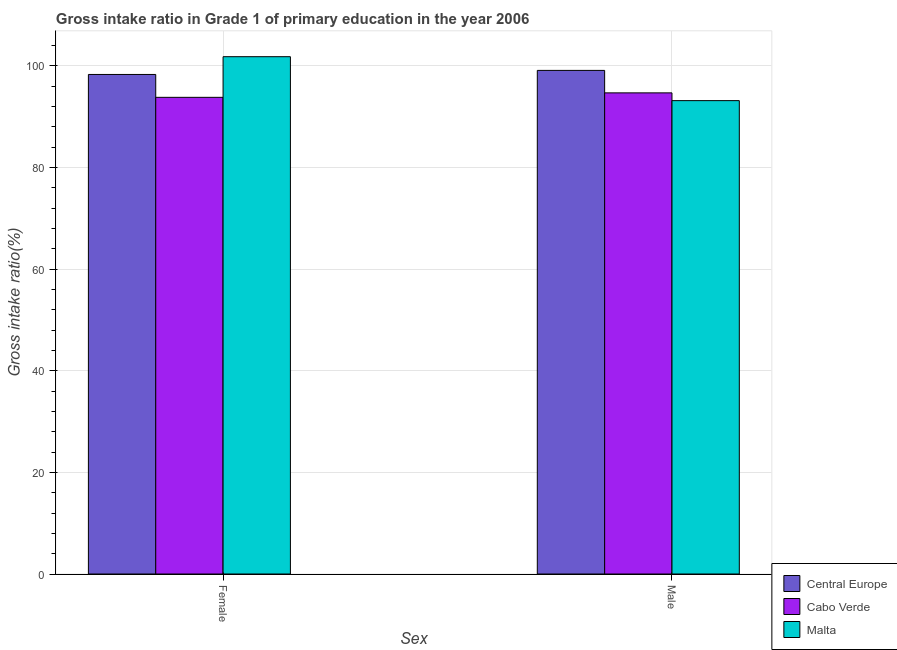How many groups of bars are there?
Make the answer very short. 2. How many bars are there on the 1st tick from the left?
Make the answer very short. 3. How many bars are there on the 1st tick from the right?
Keep it short and to the point. 3. What is the gross intake ratio(male) in Cabo Verde?
Provide a succinct answer. 94.66. Across all countries, what is the maximum gross intake ratio(male)?
Your answer should be very brief. 99.08. Across all countries, what is the minimum gross intake ratio(male)?
Provide a short and direct response. 93.13. In which country was the gross intake ratio(male) maximum?
Offer a very short reply. Central Europe. In which country was the gross intake ratio(male) minimum?
Provide a succinct answer. Malta. What is the total gross intake ratio(male) in the graph?
Your answer should be very brief. 286.87. What is the difference between the gross intake ratio(female) in Cabo Verde and that in Malta?
Keep it short and to the point. -8. What is the difference between the gross intake ratio(female) in Malta and the gross intake ratio(male) in Central Europe?
Ensure brevity in your answer.  2.7. What is the average gross intake ratio(female) per country?
Your answer should be very brief. 97.95. What is the difference between the gross intake ratio(male) and gross intake ratio(female) in Malta?
Keep it short and to the point. -8.65. In how many countries, is the gross intake ratio(female) greater than 64 %?
Make the answer very short. 3. What is the ratio of the gross intake ratio(female) in Central Europe to that in Cabo Verde?
Keep it short and to the point. 1.05. What does the 3rd bar from the left in Female represents?
Provide a succinct answer. Malta. What does the 1st bar from the right in Male represents?
Your answer should be very brief. Malta. How many bars are there?
Ensure brevity in your answer.  6. Are all the bars in the graph horizontal?
Make the answer very short. No. How many countries are there in the graph?
Your answer should be compact. 3. What is the difference between two consecutive major ticks on the Y-axis?
Make the answer very short. 20. Are the values on the major ticks of Y-axis written in scientific E-notation?
Provide a short and direct response. No. Does the graph contain any zero values?
Your response must be concise. No. Where does the legend appear in the graph?
Offer a terse response. Bottom right. How are the legend labels stacked?
Give a very brief answer. Vertical. What is the title of the graph?
Provide a succinct answer. Gross intake ratio in Grade 1 of primary education in the year 2006. Does "United Arab Emirates" appear as one of the legend labels in the graph?
Keep it short and to the point. No. What is the label or title of the X-axis?
Give a very brief answer. Sex. What is the label or title of the Y-axis?
Make the answer very short. Gross intake ratio(%). What is the Gross intake ratio(%) in Central Europe in Female?
Your answer should be compact. 98.28. What is the Gross intake ratio(%) in Cabo Verde in Female?
Your answer should be very brief. 93.78. What is the Gross intake ratio(%) in Malta in Female?
Offer a very short reply. 101.78. What is the Gross intake ratio(%) in Central Europe in Male?
Offer a terse response. 99.08. What is the Gross intake ratio(%) in Cabo Verde in Male?
Offer a very short reply. 94.66. What is the Gross intake ratio(%) of Malta in Male?
Keep it short and to the point. 93.13. Across all Sex, what is the maximum Gross intake ratio(%) in Central Europe?
Your answer should be compact. 99.08. Across all Sex, what is the maximum Gross intake ratio(%) in Cabo Verde?
Make the answer very short. 94.66. Across all Sex, what is the maximum Gross intake ratio(%) of Malta?
Your response must be concise. 101.78. Across all Sex, what is the minimum Gross intake ratio(%) of Central Europe?
Make the answer very short. 98.28. Across all Sex, what is the minimum Gross intake ratio(%) in Cabo Verde?
Offer a very short reply. 93.78. Across all Sex, what is the minimum Gross intake ratio(%) in Malta?
Give a very brief answer. 93.13. What is the total Gross intake ratio(%) in Central Europe in the graph?
Keep it short and to the point. 197.36. What is the total Gross intake ratio(%) of Cabo Verde in the graph?
Provide a succinct answer. 188.44. What is the total Gross intake ratio(%) in Malta in the graph?
Provide a short and direct response. 194.91. What is the difference between the Gross intake ratio(%) in Central Europe in Female and that in Male?
Provide a short and direct response. -0.8. What is the difference between the Gross intake ratio(%) in Cabo Verde in Female and that in Male?
Give a very brief answer. -0.88. What is the difference between the Gross intake ratio(%) in Malta in Female and that in Male?
Provide a succinct answer. 8.65. What is the difference between the Gross intake ratio(%) of Central Europe in Female and the Gross intake ratio(%) of Cabo Verde in Male?
Offer a terse response. 3.62. What is the difference between the Gross intake ratio(%) of Central Europe in Female and the Gross intake ratio(%) of Malta in Male?
Offer a very short reply. 5.15. What is the difference between the Gross intake ratio(%) of Cabo Verde in Female and the Gross intake ratio(%) of Malta in Male?
Ensure brevity in your answer.  0.65. What is the average Gross intake ratio(%) in Central Europe per Sex?
Provide a short and direct response. 98.68. What is the average Gross intake ratio(%) of Cabo Verde per Sex?
Your answer should be very brief. 94.22. What is the average Gross intake ratio(%) in Malta per Sex?
Offer a terse response. 97.45. What is the difference between the Gross intake ratio(%) of Central Europe and Gross intake ratio(%) of Cabo Verde in Female?
Provide a succinct answer. 4.5. What is the difference between the Gross intake ratio(%) of Central Europe and Gross intake ratio(%) of Malta in Female?
Your answer should be very brief. -3.5. What is the difference between the Gross intake ratio(%) of Cabo Verde and Gross intake ratio(%) of Malta in Female?
Offer a terse response. -8. What is the difference between the Gross intake ratio(%) in Central Europe and Gross intake ratio(%) in Cabo Verde in Male?
Make the answer very short. 4.42. What is the difference between the Gross intake ratio(%) in Central Europe and Gross intake ratio(%) in Malta in Male?
Ensure brevity in your answer.  5.95. What is the difference between the Gross intake ratio(%) in Cabo Verde and Gross intake ratio(%) in Malta in Male?
Offer a very short reply. 1.53. What is the ratio of the Gross intake ratio(%) in Malta in Female to that in Male?
Offer a very short reply. 1.09. What is the difference between the highest and the second highest Gross intake ratio(%) of Cabo Verde?
Offer a terse response. 0.88. What is the difference between the highest and the second highest Gross intake ratio(%) of Malta?
Give a very brief answer. 8.65. What is the difference between the highest and the lowest Gross intake ratio(%) in Cabo Verde?
Provide a short and direct response. 0.88. What is the difference between the highest and the lowest Gross intake ratio(%) in Malta?
Offer a very short reply. 8.65. 